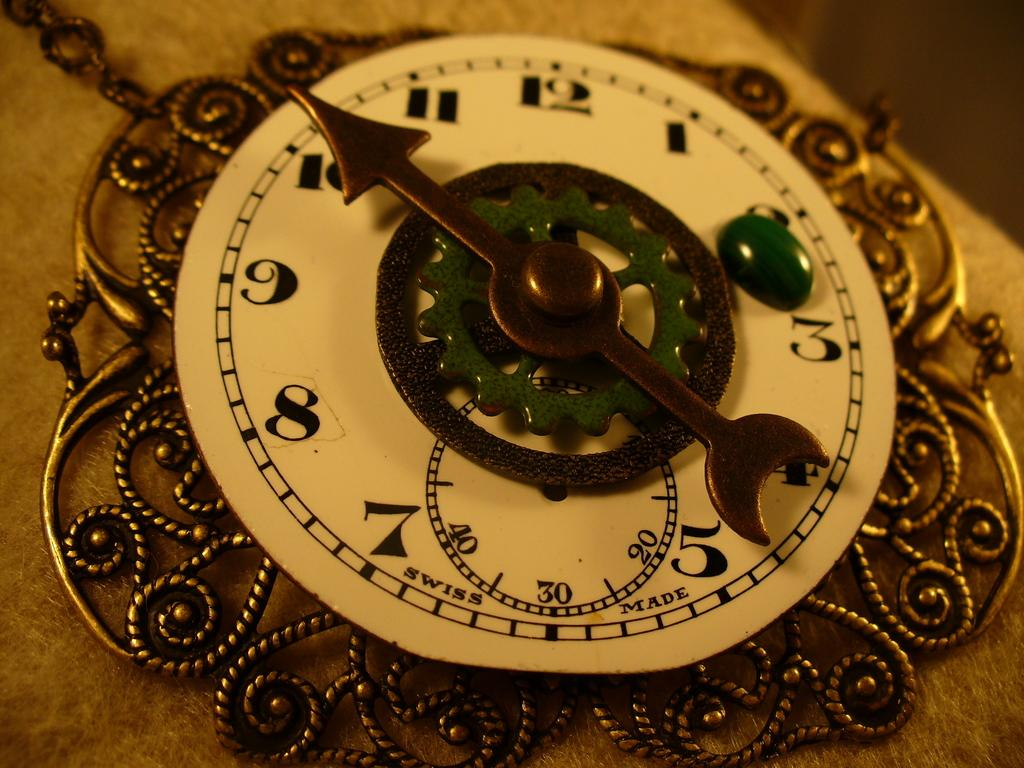<image>
Create a compact narrative representing the image presented. A swiss pocket watch current time of 10:20. 